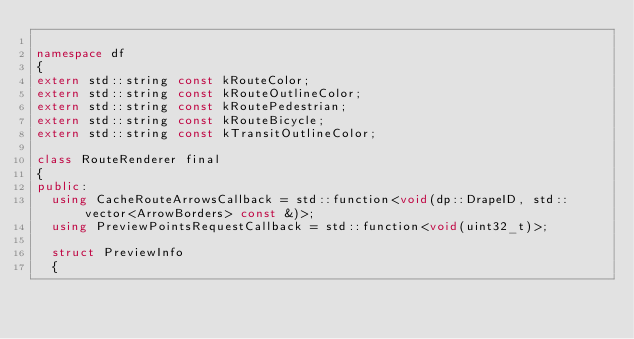Convert code to text. <code><loc_0><loc_0><loc_500><loc_500><_C++_>
namespace df
{
extern std::string const kRouteColor;
extern std::string const kRouteOutlineColor;
extern std::string const kRoutePedestrian;
extern std::string const kRouteBicycle;
extern std::string const kTransitOutlineColor;

class RouteRenderer final
{
public:
  using CacheRouteArrowsCallback = std::function<void(dp::DrapeID, std::vector<ArrowBorders> const &)>;
  using PreviewPointsRequestCallback = std::function<void(uint32_t)>;

  struct PreviewInfo
  {</code> 